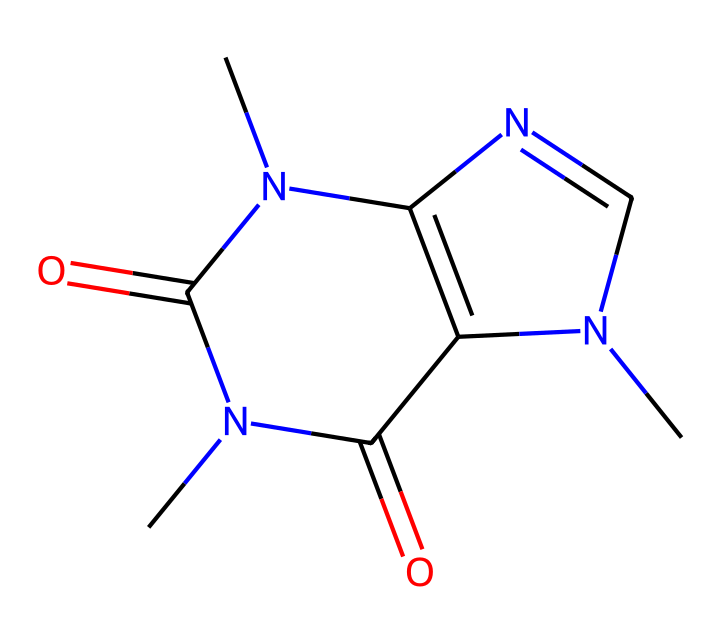What is the molecular formula of caffeine? To determine the molecular formula, we can analyze the atoms present in the SMILES representation, CN1C=NC2=C1C(=O)N(C(=O)N2C)C. Counting the carbon (C), hydrogen (H), oxygen (O), and nitrogen (N) atoms gives us the formula: C8H10N4O2.
Answer: C8H10N4O2 How many nitrogen atoms are present in caffeine? By examining the SMILES string, we can see the nitrogen atoms (N) appearing four times, indicating the presence of four nitrogen atoms in caffeine.
Answer: 4 What is the primary role of caffeine in food products? Caffeine acts as a stimulant by blocking adenosine receptors in the brain, promoting alertness and reducing fatigue, which is its primary function in food and beverages like energy drinks.
Answer: stimulant How many rings are present in the caffeine structure? Analyzing the structure, caffeine consists of two fused rings (a purine structure). Therefore, the total count of rings in caffeine is two.
Answer: 2 What type of chemical is caffeine classified as? Caffeine belongs to a class of chemicals known as methylxanthines, which are characterized by their structure comprising a xanthine base with methyl groups attached.
Answer: methylxanthine What effect do the methyl groups have on caffeine's properties? Methyl groups enhance caffeine’s lipid solubility and biological activity, influencing its absorption rate and psychoactive effects, which helps improve performance and alertness.
Answer: enhance absorption 